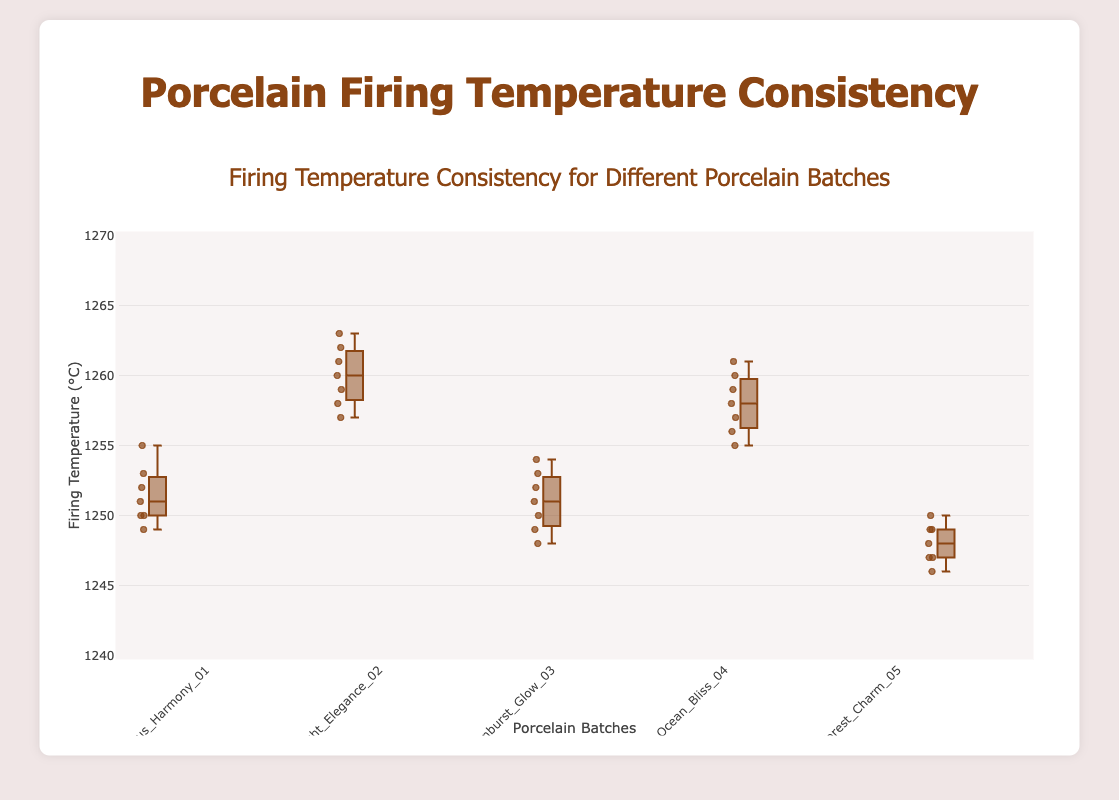How many different porcelain batches are displayed in the figure? There are five different porcelain batches displayed, each with their own box plot.
Answer: 5 What's the median firing temperature of the "Sunburst_Glow_03" batch? The median firing temperature is the middle value when the data points are ordered. For "Sunburst_Glow_03", the temperatures are [1248, 1249, 1250, 1251, 1252, 1253, 1254]. The middle value is 1251.
Answer: 1251 Which batch has the highest median firing temperature? Looking at the locations of medians in each box plot, the batch "Moonlight_Elegance_02" has the highest median line.
Answer: Moonlight_Elegance_02 What is the temperature range for the "Forest_Charm_05" batch? The temperature range is the difference between the maximum and minimum values of the whiskers. The minimum value is 1246 and the maximum value is 1250. The range is 1250 - 1246.
Answer: 4 Which batch shows the least variability in firing temperatures? The batch with the smallest interquartile range (IQR) and overall spread is "Forest_Charm_05".
Answer: Forest_Charm_05 What's the interquartile range (IQR) of the "Ocean_Bliss_04" batch? The IQR is the difference between the third quartile (Q3) and the first quartile (Q1). Q3 is the top of the box and Q1 is the bottom of the box. In "Ocean_Bliss_04", Q3 is approximately 1260 and Q1 is approximately 1256. IQR = 1260 - 1256.
Answer: 4 Compare the median firing temperatures between "Lotus_Harmony_01" and "Forest_Charm_05". Which is higher and by how much? The media in "Lotus_Harmony_01" is around 1251 and in "Forest_Charm_05" it's around 1248. The difference is 1251 - 1248.
Answer: Lotus_Harmony_01 by 3 Is there any outlier in the firing temperatures of the "Moonlight_Elegance_02" batch? Outliers in box plots are shown as individual points beyond the whiskers. For "Moonlight_Elegance_02", there are no data points beyond the whiskers.
Answer: No What is the highest firing temperature recorded across all batches? The highest temperature recorded is seen in the "Moonlight_Elegance_02" batch, which is 1263.
Answer: 1263 